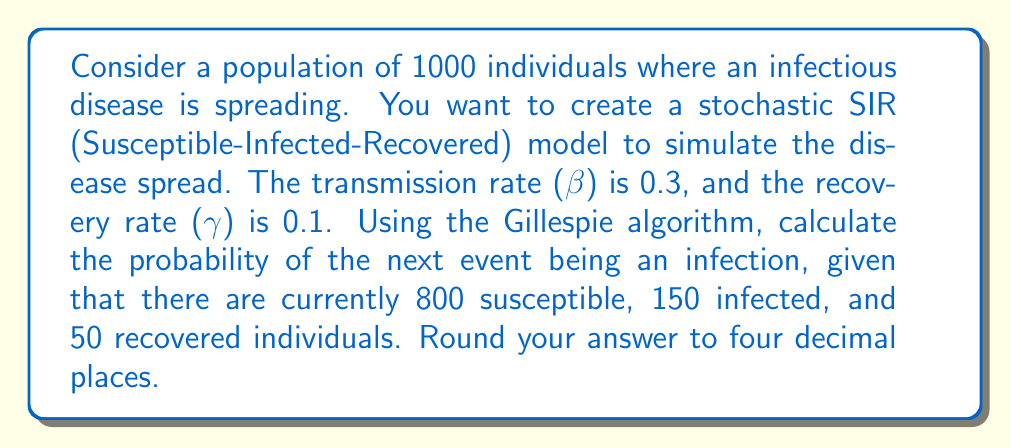What is the answer to this math problem? To solve this problem, we'll use the Gillespie algorithm, which is commonly used in stochastic simulations of chemical and biological systems. Here's a step-by-step explanation:

1. In the SIR model, we have two possible events:
   - Infection: S + I → 2I (rate: β * S * I)
   - Recovery: I → R (rate: γ * I)

2. Calculate the rate of infection:
   $$r_{\text{infection}} = \beta \cdot S \cdot I = 0.3 \cdot 800 \cdot 150 = 36000$$

3. Calculate the rate of recovery:
   $$r_{\text{recovery}} = \gamma \cdot I = 0.1 \cdot 150 = 15$$

4. Calculate the total rate:
   $$r_{\text{total}} = r_{\text{infection}} + r_{\text{recovery}} = 36000 + 15 = 36015$$

5. The probability of the next event being an infection is the ratio of the infection rate to the total rate:
   $$P(\text{infection}) = \frac{r_{\text{infection}}}{r_{\text{total}}} = \frac{36000}{36015}$$

6. Calculate the probability and round to four decimal places:
   $$P(\text{infection}) = \frac{36000}{36015} \approx 0.9996$$
Answer: 0.9996 